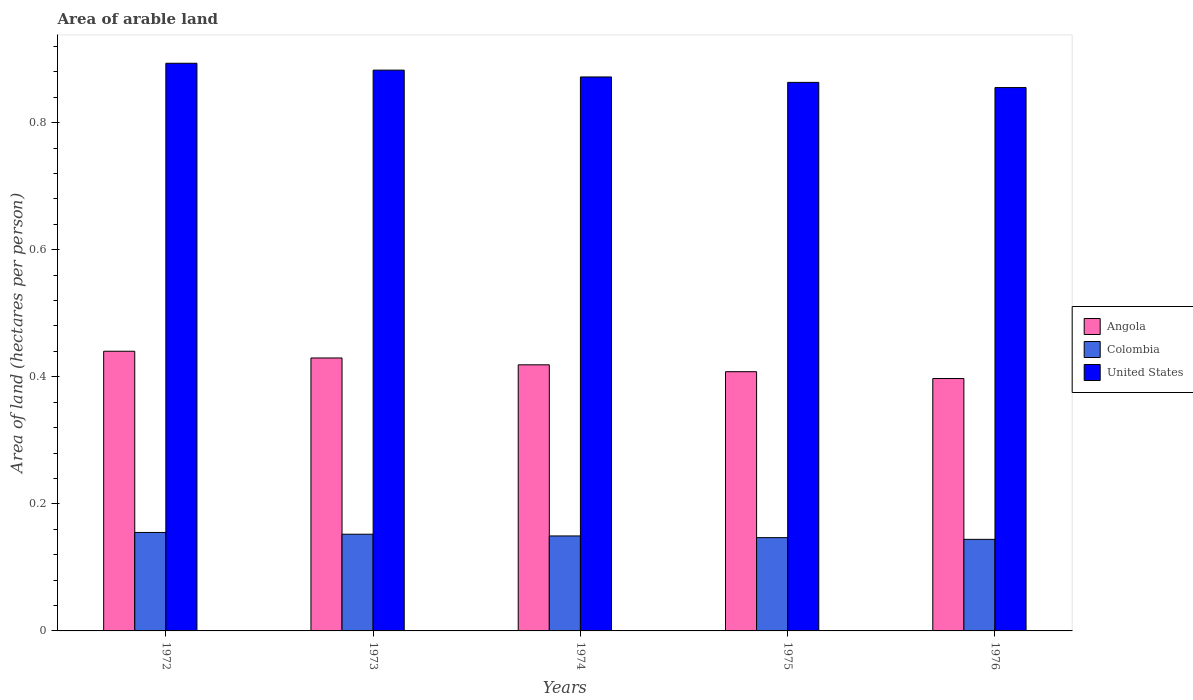How many groups of bars are there?
Your response must be concise. 5. Are the number of bars on each tick of the X-axis equal?
Give a very brief answer. Yes. How many bars are there on the 2nd tick from the left?
Make the answer very short. 3. How many bars are there on the 5th tick from the right?
Your response must be concise. 3. What is the label of the 4th group of bars from the left?
Give a very brief answer. 1975. What is the total arable land in Angola in 1973?
Provide a short and direct response. 0.43. Across all years, what is the maximum total arable land in Colombia?
Your response must be concise. 0.16. Across all years, what is the minimum total arable land in Colombia?
Offer a very short reply. 0.14. In which year was the total arable land in Colombia maximum?
Make the answer very short. 1972. In which year was the total arable land in Colombia minimum?
Your answer should be very brief. 1976. What is the total total arable land in United States in the graph?
Offer a very short reply. 4.37. What is the difference between the total arable land in Colombia in 1972 and that in 1974?
Your answer should be compact. 0.01. What is the difference between the total arable land in United States in 1973 and the total arable land in Angola in 1974?
Give a very brief answer. 0.46. What is the average total arable land in United States per year?
Provide a short and direct response. 0.87. In the year 1974, what is the difference between the total arable land in Colombia and total arable land in United States?
Offer a terse response. -0.72. What is the ratio of the total arable land in United States in 1974 to that in 1976?
Keep it short and to the point. 1.02. Is the difference between the total arable land in Colombia in 1973 and 1975 greater than the difference between the total arable land in United States in 1973 and 1975?
Provide a succinct answer. No. What is the difference between the highest and the second highest total arable land in Colombia?
Offer a terse response. 0. What is the difference between the highest and the lowest total arable land in Colombia?
Make the answer very short. 0.01. In how many years, is the total arable land in Angola greater than the average total arable land in Angola taken over all years?
Offer a very short reply. 3. What does the 2nd bar from the left in 1975 represents?
Offer a terse response. Colombia. What does the 1st bar from the right in 1976 represents?
Keep it short and to the point. United States. How many bars are there?
Keep it short and to the point. 15. Are the values on the major ticks of Y-axis written in scientific E-notation?
Provide a short and direct response. No. How many legend labels are there?
Make the answer very short. 3. How are the legend labels stacked?
Keep it short and to the point. Vertical. What is the title of the graph?
Your response must be concise. Area of arable land. What is the label or title of the X-axis?
Your answer should be compact. Years. What is the label or title of the Y-axis?
Ensure brevity in your answer.  Area of land (hectares per person). What is the Area of land (hectares per person) in Angola in 1972?
Provide a succinct answer. 0.44. What is the Area of land (hectares per person) of Colombia in 1972?
Keep it short and to the point. 0.16. What is the Area of land (hectares per person) of United States in 1972?
Your answer should be compact. 0.89. What is the Area of land (hectares per person) in Angola in 1973?
Keep it short and to the point. 0.43. What is the Area of land (hectares per person) of Colombia in 1973?
Provide a succinct answer. 0.15. What is the Area of land (hectares per person) in United States in 1973?
Give a very brief answer. 0.88. What is the Area of land (hectares per person) of Angola in 1974?
Give a very brief answer. 0.42. What is the Area of land (hectares per person) of Colombia in 1974?
Your response must be concise. 0.15. What is the Area of land (hectares per person) of United States in 1974?
Provide a short and direct response. 0.87. What is the Area of land (hectares per person) in Angola in 1975?
Offer a very short reply. 0.41. What is the Area of land (hectares per person) of Colombia in 1975?
Offer a very short reply. 0.15. What is the Area of land (hectares per person) of United States in 1975?
Offer a terse response. 0.86. What is the Area of land (hectares per person) of Angola in 1976?
Offer a very short reply. 0.4. What is the Area of land (hectares per person) in Colombia in 1976?
Your response must be concise. 0.14. What is the Area of land (hectares per person) in United States in 1976?
Your answer should be compact. 0.86. Across all years, what is the maximum Area of land (hectares per person) of Angola?
Offer a terse response. 0.44. Across all years, what is the maximum Area of land (hectares per person) of Colombia?
Keep it short and to the point. 0.16. Across all years, what is the maximum Area of land (hectares per person) of United States?
Offer a terse response. 0.89. Across all years, what is the minimum Area of land (hectares per person) in Angola?
Make the answer very short. 0.4. Across all years, what is the minimum Area of land (hectares per person) of Colombia?
Keep it short and to the point. 0.14. Across all years, what is the minimum Area of land (hectares per person) of United States?
Your answer should be very brief. 0.86. What is the total Area of land (hectares per person) in Angola in the graph?
Your answer should be compact. 2.09. What is the total Area of land (hectares per person) in Colombia in the graph?
Your answer should be compact. 0.75. What is the total Area of land (hectares per person) of United States in the graph?
Make the answer very short. 4.37. What is the difference between the Area of land (hectares per person) of Angola in 1972 and that in 1973?
Offer a very short reply. 0.01. What is the difference between the Area of land (hectares per person) of Colombia in 1972 and that in 1973?
Offer a very short reply. 0. What is the difference between the Area of land (hectares per person) in United States in 1972 and that in 1973?
Your response must be concise. 0.01. What is the difference between the Area of land (hectares per person) in Angola in 1972 and that in 1974?
Provide a short and direct response. 0.02. What is the difference between the Area of land (hectares per person) of Colombia in 1972 and that in 1974?
Your answer should be very brief. 0.01. What is the difference between the Area of land (hectares per person) of United States in 1972 and that in 1974?
Provide a succinct answer. 0.02. What is the difference between the Area of land (hectares per person) in Angola in 1972 and that in 1975?
Provide a succinct answer. 0.03. What is the difference between the Area of land (hectares per person) in Colombia in 1972 and that in 1975?
Keep it short and to the point. 0.01. What is the difference between the Area of land (hectares per person) in United States in 1972 and that in 1975?
Give a very brief answer. 0.03. What is the difference between the Area of land (hectares per person) in Angola in 1972 and that in 1976?
Offer a terse response. 0.04. What is the difference between the Area of land (hectares per person) in Colombia in 1972 and that in 1976?
Make the answer very short. 0.01. What is the difference between the Area of land (hectares per person) of United States in 1972 and that in 1976?
Provide a succinct answer. 0.04. What is the difference between the Area of land (hectares per person) of Angola in 1973 and that in 1974?
Provide a short and direct response. 0.01. What is the difference between the Area of land (hectares per person) in Colombia in 1973 and that in 1974?
Offer a terse response. 0. What is the difference between the Area of land (hectares per person) in United States in 1973 and that in 1974?
Provide a succinct answer. 0.01. What is the difference between the Area of land (hectares per person) of Angola in 1973 and that in 1975?
Provide a succinct answer. 0.02. What is the difference between the Area of land (hectares per person) of Colombia in 1973 and that in 1975?
Keep it short and to the point. 0.01. What is the difference between the Area of land (hectares per person) of United States in 1973 and that in 1975?
Your answer should be very brief. 0.02. What is the difference between the Area of land (hectares per person) in Angola in 1973 and that in 1976?
Your answer should be very brief. 0.03. What is the difference between the Area of land (hectares per person) in Colombia in 1973 and that in 1976?
Ensure brevity in your answer.  0.01. What is the difference between the Area of land (hectares per person) of United States in 1973 and that in 1976?
Provide a short and direct response. 0.03. What is the difference between the Area of land (hectares per person) in Angola in 1974 and that in 1975?
Your response must be concise. 0.01. What is the difference between the Area of land (hectares per person) in Colombia in 1974 and that in 1975?
Ensure brevity in your answer.  0. What is the difference between the Area of land (hectares per person) in United States in 1974 and that in 1975?
Your response must be concise. 0.01. What is the difference between the Area of land (hectares per person) of Angola in 1974 and that in 1976?
Provide a succinct answer. 0.02. What is the difference between the Area of land (hectares per person) of Colombia in 1974 and that in 1976?
Offer a very short reply. 0.01. What is the difference between the Area of land (hectares per person) of United States in 1974 and that in 1976?
Offer a very short reply. 0.02. What is the difference between the Area of land (hectares per person) of Angola in 1975 and that in 1976?
Your answer should be compact. 0.01. What is the difference between the Area of land (hectares per person) of Colombia in 1975 and that in 1976?
Offer a very short reply. 0. What is the difference between the Area of land (hectares per person) in United States in 1975 and that in 1976?
Offer a terse response. 0.01. What is the difference between the Area of land (hectares per person) in Angola in 1972 and the Area of land (hectares per person) in Colombia in 1973?
Provide a succinct answer. 0.29. What is the difference between the Area of land (hectares per person) of Angola in 1972 and the Area of land (hectares per person) of United States in 1973?
Give a very brief answer. -0.44. What is the difference between the Area of land (hectares per person) in Colombia in 1972 and the Area of land (hectares per person) in United States in 1973?
Give a very brief answer. -0.73. What is the difference between the Area of land (hectares per person) in Angola in 1972 and the Area of land (hectares per person) in Colombia in 1974?
Your answer should be very brief. 0.29. What is the difference between the Area of land (hectares per person) of Angola in 1972 and the Area of land (hectares per person) of United States in 1974?
Your answer should be very brief. -0.43. What is the difference between the Area of land (hectares per person) in Colombia in 1972 and the Area of land (hectares per person) in United States in 1974?
Your answer should be compact. -0.72. What is the difference between the Area of land (hectares per person) in Angola in 1972 and the Area of land (hectares per person) in Colombia in 1975?
Offer a very short reply. 0.29. What is the difference between the Area of land (hectares per person) in Angola in 1972 and the Area of land (hectares per person) in United States in 1975?
Ensure brevity in your answer.  -0.42. What is the difference between the Area of land (hectares per person) of Colombia in 1972 and the Area of land (hectares per person) of United States in 1975?
Ensure brevity in your answer.  -0.71. What is the difference between the Area of land (hectares per person) in Angola in 1972 and the Area of land (hectares per person) in Colombia in 1976?
Offer a very short reply. 0.3. What is the difference between the Area of land (hectares per person) of Angola in 1972 and the Area of land (hectares per person) of United States in 1976?
Give a very brief answer. -0.41. What is the difference between the Area of land (hectares per person) in Colombia in 1972 and the Area of land (hectares per person) in United States in 1976?
Provide a succinct answer. -0.7. What is the difference between the Area of land (hectares per person) in Angola in 1973 and the Area of land (hectares per person) in Colombia in 1974?
Give a very brief answer. 0.28. What is the difference between the Area of land (hectares per person) of Angola in 1973 and the Area of land (hectares per person) of United States in 1974?
Offer a terse response. -0.44. What is the difference between the Area of land (hectares per person) of Colombia in 1973 and the Area of land (hectares per person) of United States in 1974?
Provide a succinct answer. -0.72. What is the difference between the Area of land (hectares per person) of Angola in 1973 and the Area of land (hectares per person) of Colombia in 1975?
Make the answer very short. 0.28. What is the difference between the Area of land (hectares per person) in Angola in 1973 and the Area of land (hectares per person) in United States in 1975?
Give a very brief answer. -0.43. What is the difference between the Area of land (hectares per person) in Colombia in 1973 and the Area of land (hectares per person) in United States in 1975?
Offer a terse response. -0.71. What is the difference between the Area of land (hectares per person) of Angola in 1973 and the Area of land (hectares per person) of Colombia in 1976?
Your answer should be very brief. 0.29. What is the difference between the Area of land (hectares per person) of Angola in 1973 and the Area of land (hectares per person) of United States in 1976?
Make the answer very short. -0.43. What is the difference between the Area of land (hectares per person) in Colombia in 1973 and the Area of land (hectares per person) in United States in 1976?
Your answer should be compact. -0.7. What is the difference between the Area of land (hectares per person) of Angola in 1974 and the Area of land (hectares per person) of Colombia in 1975?
Provide a succinct answer. 0.27. What is the difference between the Area of land (hectares per person) in Angola in 1974 and the Area of land (hectares per person) in United States in 1975?
Provide a succinct answer. -0.44. What is the difference between the Area of land (hectares per person) of Colombia in 1974 and the Area of land (hectares per person) of United States in 1975?
Provide a succinct answer. -0.71. What is the difference between the Area of land (hectares per person) of Angola in 1974 and the Area of land (hectares per person) of Colombia in 1976?
Provide a succinct answer. 0.27. What is the difference between the Area of land (hectares per person) in Angola in 1974 and the Area of land (hectares per person) in United States in 1976?
Ensure brevity in your answer.  -0.44. What is the difference between the Area of land (hectares per person) in Colombia in 1974 and the Area of land (hectares per person) in United States in 1976?
Keep it short and to the point. -0.71. What is the difference between the Area of land (hectares per person) in Angola in 1975 and the Area of land (hectares per person) in Colombia in 1976?
Your answer should be compact. 0.26. What is the difference between the Area of land (hectares per person) in Angola in 1975 and the Area of land (hectares per person) in United States in 1976?
Your answer should be very brief. -0.45. What is the difference between the Area of land (hectares per person) of Colombia in 1975 and the Area of land (hectares per person) of United States in 1976?
Offer a terse response. -0.71. What is the average Area of land (hectares per person) of Angola per year?
Offer a very short reply. 0.42. What is the average Area of land (hectares per person) in Colombia per year?
Make the answer very short. 0.15. What is the average Area of land (hectares per person) in United States per year?
Keep it short and to the point. 0.87. In the year 1972, what is the difference between the Area of land (hectares per person) of Angola and Area of land (hectares per person) of Colombia?
Offer a terse response. 0.29. In the year 1972, what is the difference between the Area of land (hectares per person) of Angola and Area of land (hectares per person) of United States?
Your answer should be very brief. -0.45. In the year 1972, what is the difference between the Area of land (hectares per person) of Colombia and Area of land (hectares per person) of United States?
Offer a terse response. -0.74. In the year 1973, what is the difference between the Area of land (hectares per person) of Angola and Area of land (hectares per person) of Colombia?
Give a very brief answer. 0.28. In the year 1973, what is the difference between the Area of land (hectares per person) of Angola and Area of land (hectares per person) of United States?
Ensure brevity in your answer.  -0.45. In the year 1973, what is the difference between the Area of land (hectares per person) in Colombia and Area of land (hectares per person) in United States?
Ensure brevity in your answer.  -0.73. In the year 1974, what is the difference between the Area of land (hectares per person) of Angola and Area of land (hectares per person) of Colombia?
Your answer should be very brief. 0.27. In the year 1974, what is the difference between the Area of land (hectares per person) in Angola and Area of land (hectares per person) in United States?
Give a very brief answer. -0.45. In the year 1974, what is the difference between the Area of land (hectares per person) in Colombia and Area of land (hectares per person) in United States?
Offer a terse response. -0.72. In the year 1975, what is the difference between the Area of land (hectares per person) in Angola and Area of land (hectares per person) in Colombia?
Ensure brevity in your answer.  0.26. In the year 1975, what is the difference between the Area of land (hectares per person) of Angola and Area of land (hectares per person) of United States?
Offer a terse response. -0.46. In the year 1975, what is the difference between the Area of land (hectares per person) in Colombia and Area of land (hectares per person) in United States?
Provide a short and direct response. -0.72. In the year 1976, what is the difference between the Area of land (hectares per person) of Angola and Area of land (hectares per person) of Colombia?
Offer a very short reply. 0.25. In the year 1976, what is the difference between the Area of land (hectares per person) of Angola and Area of land (hectares per person) of United States?
Keep it short and to the point. -0.46. In the year 1976, what is the difference between the Area of land (hectares per person) of Colombia and Area of land (hectares per person) of United States?
Keep it short and to the point. -0.71. What is the ratio of the Area of land (hectares per person) of Angola in 1972 to that in 1973?
Offer a terse response. 1.02. What is the ratio of the Area of land (hectares per person) in Colombia in 1972 to that in 1973?
Ensure brevity in your answer.  1.02. What is the ratio of the Area of land (hectares per person) in United States in 1972 to that in 1973?
Offer a terse response. 1.01. What is the ratio of the Area of land (hectares per person) of Angola in 1972 to that in 1974?
Make the answer very short. 1.05. What is the ratio of the Area of land (hectares per person) in Colombia in 1972 to that in 1974?
Give a very brief answer. 1.04. What is the ratio of the Area of land (hectares per person) in United States in 1972 to that in 1974?
Give a very brief answer. 1.02. What is the ratio of the Area of land (hectares per person) of Angola in 1972 to that in 1975?
Your answer should be very brief. 1.08. What is the ratio of the Area of land (hectares per person) of Colombia in 1972 to that in 1975?
Ensure brevity in your answer.  1.06. What is the ratio of the Area of land (hectares per person) in United States in 1972 to that in 1975?
Provide a succinct answer. 1.03. What is the ratio of the Area of land (hectares per person) in Angola in 1972 to that in 1976?
Provide a succinct answer. 1.11. What is the ratio of the Area of land (hectares per person) of Colombia in 1972 to that in 1976?
Make the answer very short. 1.08. What is the ratio of the Area of land (hectares per person) of United States in 1972 to that in 1976?
Offer a very short reply. 1.04. What is the ratio of the Area of land (hectares per person) in Angola in 1973 to that in 1974?
Offer a very short reply. 1.03. What is the ratio of the Area of land (hectares per person) of Colombia in 1973 to that in 1974?
Give a very brief answer. 1.02. What is the ratio of the Area of land (hectares per person) of United States in 1973 to that in 1974?
Your answer should be very brief. 1.01. What is the ratio of the Area of land (hectares per person) in Angola in 1973 to that in 1975?
Your answer should be compact. 1.05. What is the ratio of the Area of land (hectares per person) of Colombia in 1973 to that in 1975?
Your answer should be compact. 1.04. What is the ratio of the Area of land (hectares per person) in United States in 1973 to that in 1975?
Ensure brevity in your answer.  1.02. What is the ratio of the Area of land (hectares per person) of Angola in 1973 to that in 1976?
Offer a terse response. 1.08. What is the ratio of the Area of land (hectares per person) in Colombia in 1973 to that in 1976?
Your response must be concise. 1.06. What is the ratio of the Area of land (hectares per person) of United States in 1973 to that in 1976?
Make the answer very short. 1.03. What is the ratio of the Area of land (hectares per person) in Angola in 1974 to that in 1975?
Ensure brevity in your answer.  1.03. What is the ratio of the Area of land (hectares per person) of Colombia in 1974 to that in 1975?
Give a very brief answer. 1.02. What is the ratio of the Area of land (hectares per person) in United States in 1974 to that in 1975?
Provide a short and direct response. 1.01. What is the ratio of the Area of land (hectares per person) in Angola in 1974 to that in 1976?
Make the answer very short. 1.05. What is the ratio of the Area of land (hectares per person) in Colombia in 1974 to that in 1976?
Offer a very short reply. 1.04. What is the ratio of the Area of land (hectares per person) of United States in 1974 to that in 1976?
Offer a very short reply. 1.02. What is the ratio of the Area of land (hectares per person) in Angola in 1975 to that in 1976?
Provide a succinct answer. 1.03. What is the ratio of the Area of land (hectares per person) of Colombia in 1975 to that in 1976?
Ensure brevity in your answer.  1.02. What is the ratio of the Area of land (hectares per person) in United States in 1975 to that in 1976?
Give a very brief answer. 1.01. What is the difference between the highest and the second highest Area of land (hectares per person) of Angola?
Give a very brief answer. 0.01. What is the difference between the highest and the second highest Area of land (hectares per person) in Colombia?
Your response must be concise. 0. What is the difference between the highest and the second highest Area of land (hectares per person) in United States?
Your answer should be compact. 0.01. What is the difference between the highest and the lowest Area of land (hectares per person) of Angola?
Offer a terse response. 0.04. What is the difference between the highest and the lowest Area of land (hectares per person) of Colombia?
Your response must be concise. 0.01. What is the difference between the highest and the lowest Area of land (hectares per person) in United States?
Your answer should be very brief. 0.04. 